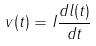<formula> <loc_0><loc_0><loc_500><loc_500>v ( t ) = I \frac { d l ( t ) } { d t }</formula> 